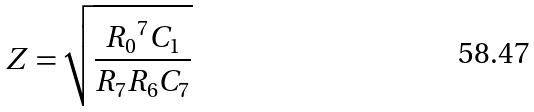Convert formula to latex. <formula><loc_0><loc_0><loc_500><loc_500>Z = \sqrt { \frac { { R _ { 0 } } ^ { 7 } C _ { 1 } } { R _ { 7 } R _ { 6 } C _ { 7 } } }</formula> 